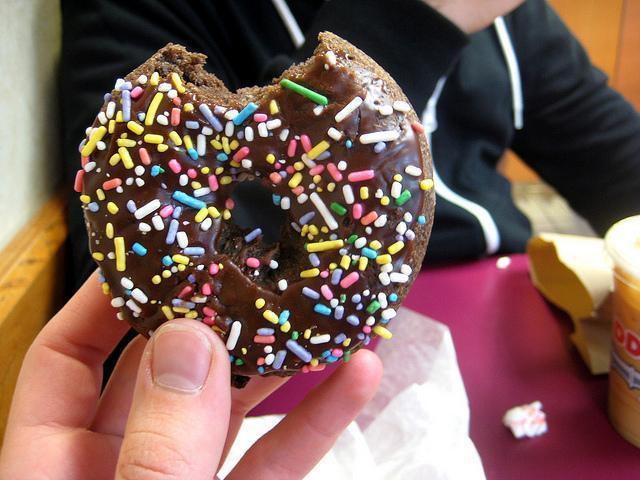Evaluate: Does the caption "The donut is on the dining table." match the image?
Answer yes or no. No. 